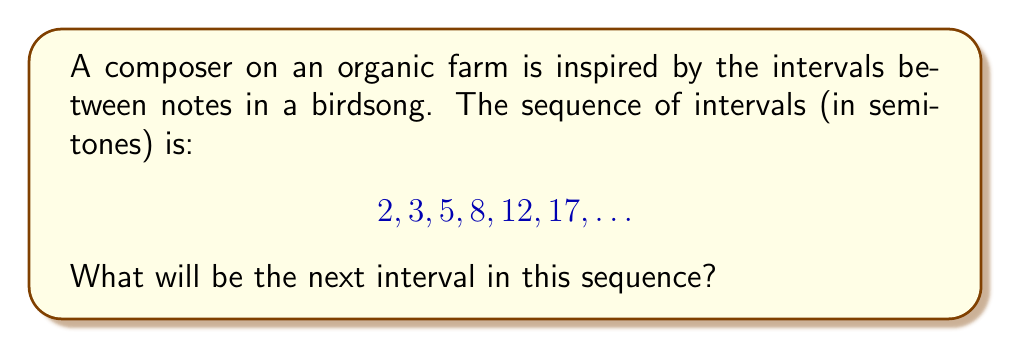Can you answer this question? Let's approach this step-by-step:

1) First, let's look at the differences between consecutive terms:
   $2 \rightarrow 3$: difference of 1
   $3 \rightarrow 5$: difference of 2
   $5 \rightarrow 8$: difference of 3
   $8 \rightarrow 12$: difference of 4
   $12 \rightarrow 17$: difference of 5

2) We can see that the differences are increasing by 1 each time.

3) This suggests that the sequence follows the pattern of a quadratic sequence, where the second differences are constant.

4) Let's confirm this by calculating the second differences:
   First differences: 1, 2, 3, 4, 5
   Second differences: 1, 1, 1, 1

5) Indeed, the second differences are constant (1), confirming it's a quadratic sequence.

6) For a quadratic sequence, the nth term can be represented as:
   $$a_n = \frac{1}{2}n^2 + bn + c$$
   where $a$, $b$, and $c$ are constants.

7) Given that the second difference is 1, we know that $a = \frac{1}{2}$.

8) We can find $b$ and $c$ by using the first two terms:
   For $n=1$: $2 = \frac{1}{2} + b + c$
   For $n=2$: $3 = 2 + 2b + c$

9) Solving these equations:
   $b = \frac{1}{2}$ and $c = 1$

10) Therefore, the nth term of the sequence is:
    $$a_n = \frac{1}{2}n^2 + \frac{1}{2}n + 1$$

11) To find the next term, we need to calculate $a_7$:
    $$a_7 = \frac{1}{2}(7^2) + \frac{1}{2}(7) + 1 = 24.5 + 3.5 + 1 = 29$$
Answer: 29 